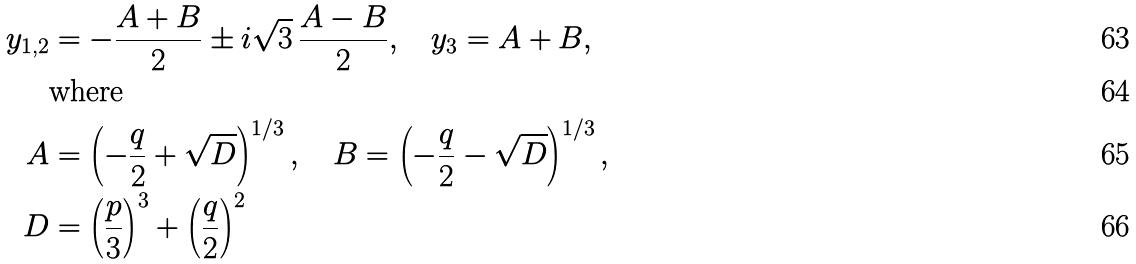<formula> <loc_0><loc_0><loc_500><loc_500>y _ { 1 , 2 } & = - \frac { A + B } { 2 } \pm i \sqrt { 3 } \, \frac { A - B } { 2 } , \quad y _ { 3 } = A + B , \\ & \text {where} \\ A & = \left ( - \frac { q } { 2 } + \sqrt { D } \right ) ^ { 1 / 3 } , \quad B = \left ( - \frac { q } { 2 } - \sqrt { D } \right ) ^ { 1 / 3 } , \\ D & = \left ( \frac { p } { 3 } \right ) ^ { 3 } + \left ( \frac { q } { 2 } \right ) ^ { 2 }</formula> 